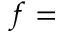Convert formula to latex. <formula><loc_0><loc_0><loc_500><loc_500>f =</formula> 